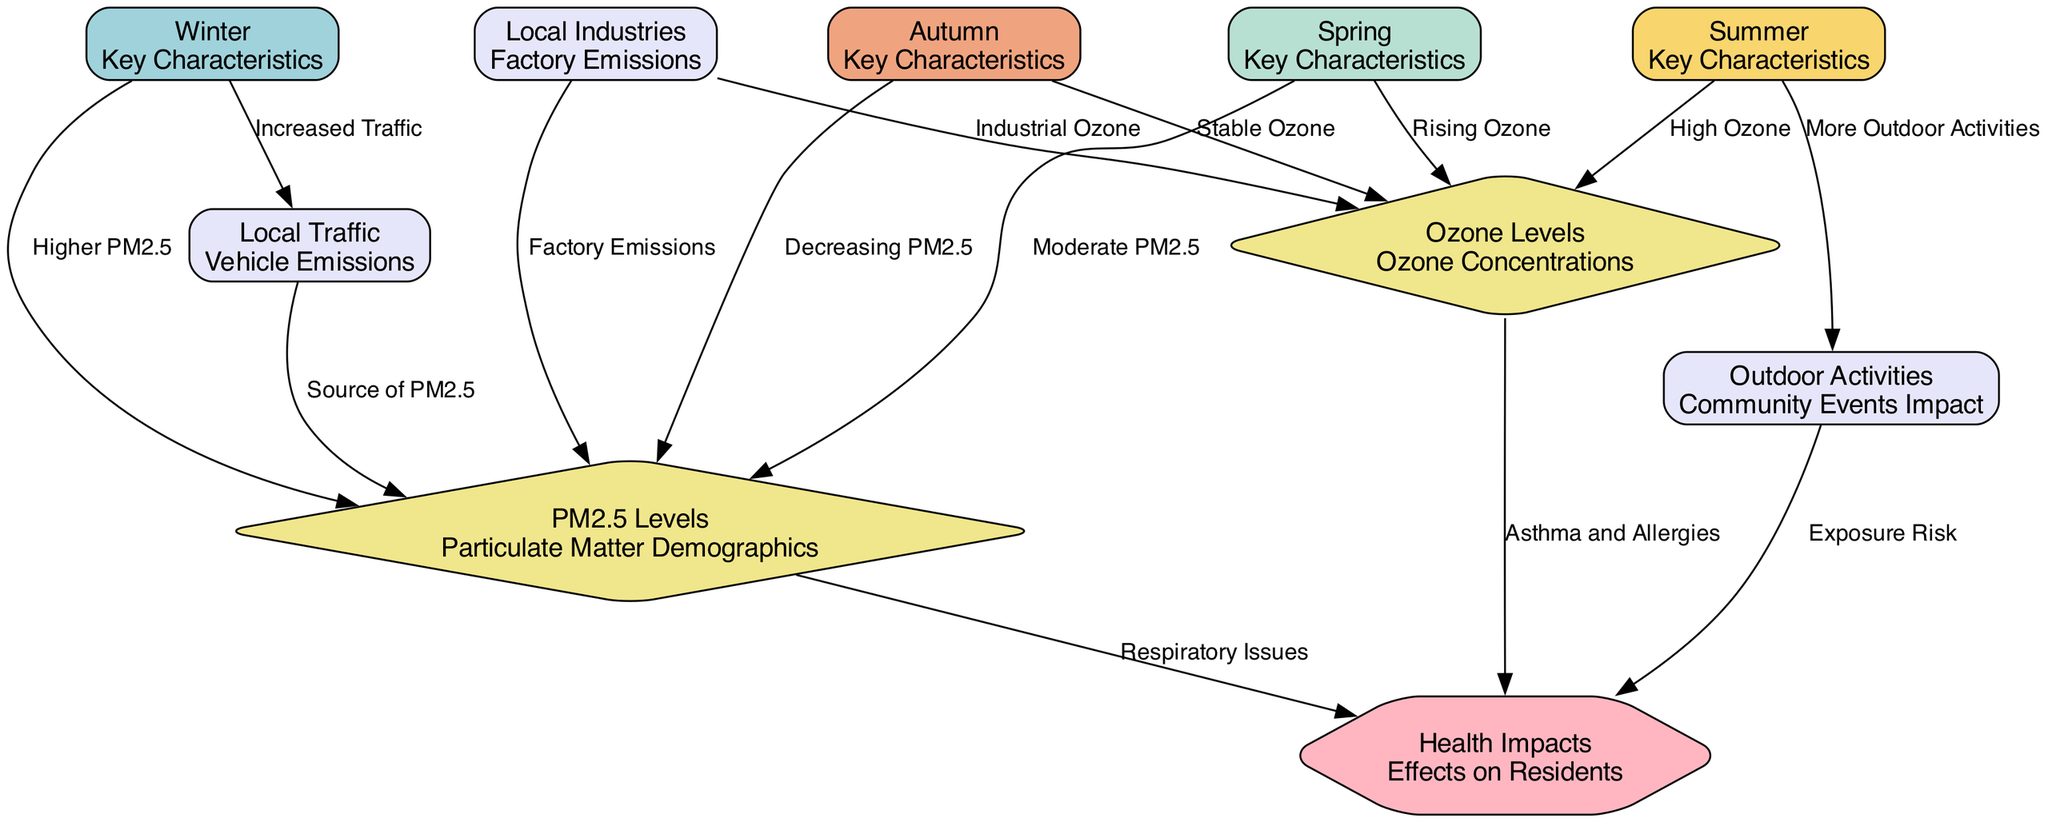What season is associated with higher PM2.5 levels? The diagram indicates that Winter is related to higher PM2.5 levels, as shown by the edge labeled "Higher PM2.5" pointing from Winter to PM2.5 Levels.
Answer: Winter How many nodes represent the different seasons? From the diagram, there are four nodes that represent the different seasons: Winter, Spring, Summer, and Autumn.
Answer: 4 Which season has high ozone levels? The diagram highlights Summer with the edge labeled "High Ozone" indicating it is associated with high ozone levels.
Answer: Summer What is the relationship between local traffic and PM2.5 levels in Winter? The edge labeled "Increased Traffic" from Winter to PM2.5 Levels shows that local traffic increases PM2.5 levels during Winter.
Answer: Increased Traffic Which health impacts are linked to PM2.5 levels? The diagram shows that PM2.5 levels are linked to "Respiratory Issues" as indicated by the edge from PM2.5 Levels to Health Impacts labeled "Respiratory Issues".
Answer: Respiratory Issues What seasonal activity increases ozone levels in Spring? The diagram indicates that there is a rising ozone level during Spring, which is shown by the edge labeled "Rising Ozone" from Spring to Ozone Levels.
Answer: Rising Ozone How does outdoor activity in Summer impact health? The diagram indicates that outdoor activities in Summer are related to health impacts through the "Exposure Risk," as shown by the edge from Outdoor Activities to Health Impacts.
Answer: Exposure Risk What effect do local industries have on PM2.5 levels? The edge labeled "Factory Emissions" from Local Industries to PM2.5 Levels indicates that local industries increase PM2.5 levels due to their emissions.
Answer: Factory Emissions What is the connection between Autumn and PM2.5 levels? The diagram indicates that Autumn has a relationship with decreasing PM2.5 levels, as shown by the edge labeled "Decreasing PM2.5" pointing from Autumn to PM2.5 Levels.
Answer: Decreasing PM2.5 